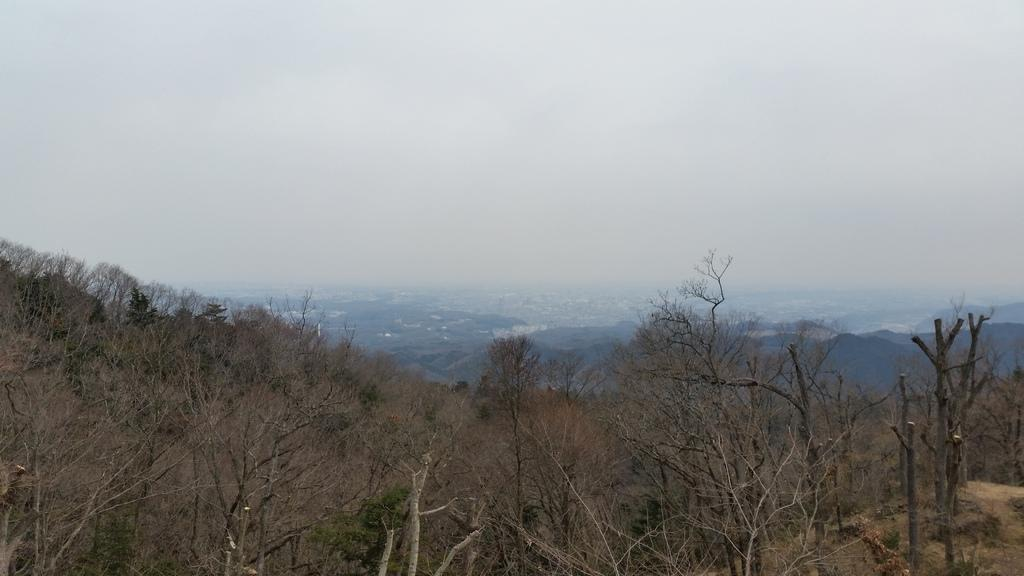What type of vegetation can be seen at the bottom of the image? There are dry trees in the front bottom side of the image. What natural feature is visible in the background of the image? There are mountains visible in the background of the image. What is the value of the tooth in the image? There is no tooth present in the image, so it is not possible to determine its value. 